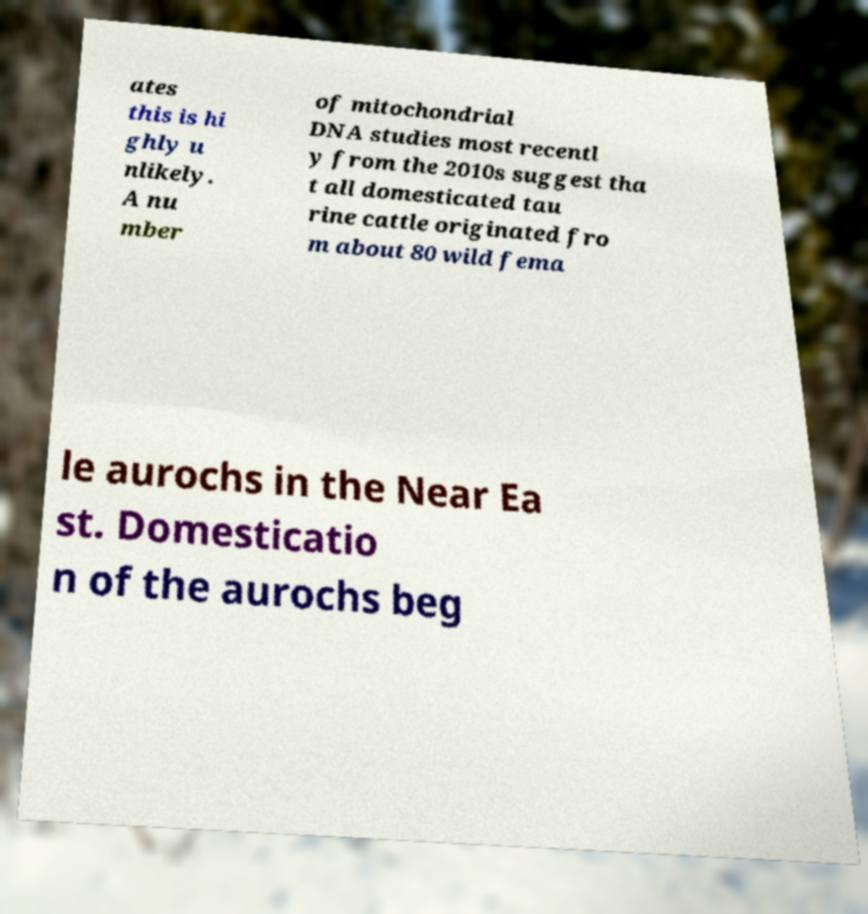For documentation purposes, I need the text within this image transcribed. Could you provide that? ates this is hi ghly u nlikely. A nu mber of mitochondrial DNA studies most recentl y from the 2010s suggest tha t all domesticated tau rine cattle originated fro m about 80 wild fema le aurochs in the Near Ea st. Domesticatio n of the aurochs beg 